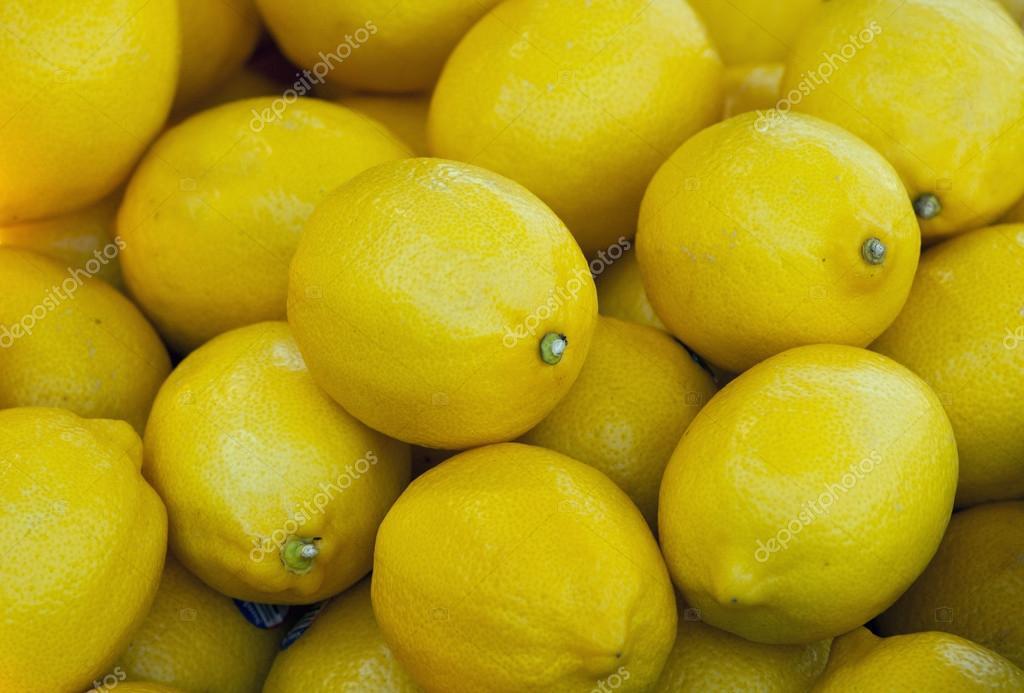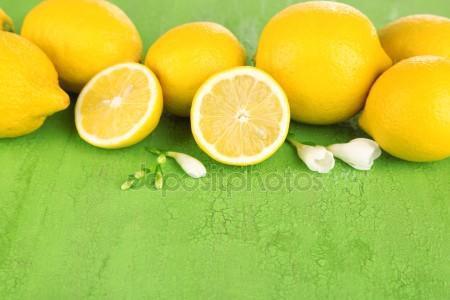The first image is the image on the left, the second image is the image on the right. Assess this claim about the two images: "There are at least two lemon halves that are cut open.". Correct or not? Answer yes or no. Yes. The first image is the image on the left, the second image is the image on the right. For the images displayed, is the sentence "There is a sliced lemon in exactly one image." factually correct? Answer yes or no. Yes. 